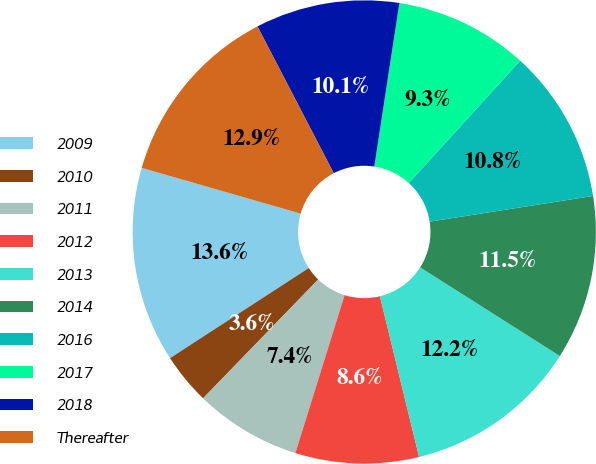<chart> <loc_0><loc_0><loc_500><loc_500><pie_chart><fcel>2009<fcel>2010<fcel>2011<fcel>2012<fcel>2013<fcel>2014<fcel>2016<fcel>2017<fcel>2018<fcel>Thereafter<nl><fcel>13.63%<fcel>3.58%<fcel>7.44%<fcel>8.61%<fcel>12.2%<fcel>11.48%<fcel>10.76%<fcel>9.33%<fcel>10.05%<fcel>12.91%<nl></chart> 